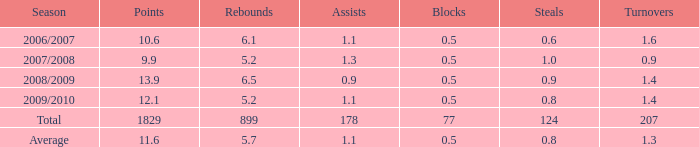2? 0.0. 